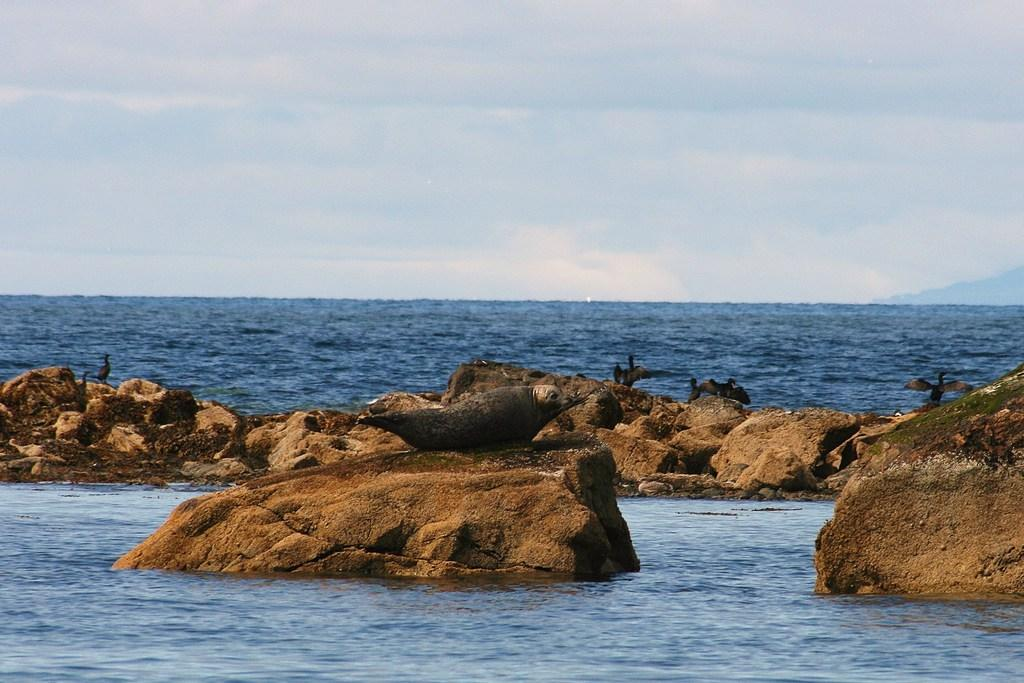What animals can be seen in the image? There are birds on the rocks in the image. What natural element is present in the image? There is water visible in the image. What can be seen in the background of the image? The sky with clouds is visible in the background of the image. What type of wool is being used by the birds in the image? There is no wool present in the image; the birds are on the rocks and not using any wool. 